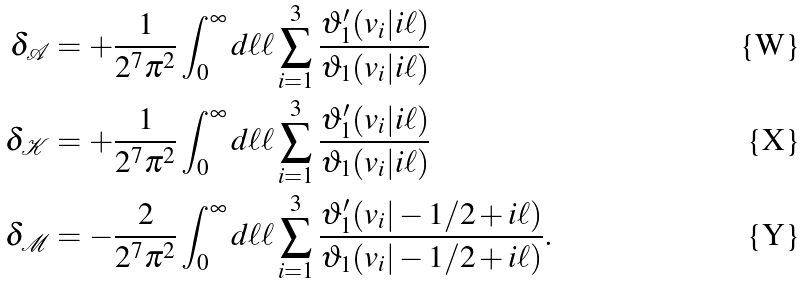<formula> <loc_0><loc_0><loc_500><loc_500>\delta _ { \mathcal { A } } & = + \frac { 1 } { 2 ^ { 7 } \pi ^ { 2 } } \int _ { 0 } ^ { \infty } d \ell \ell \sum _ { i = 1 } ^ { 3 } \frac { \vartheta _ { 1 } ^ { \prime } ( v _ { i } | i \ell ) } { \vartheta _ { 1 } ( v _ { i } | i \ell ) } \\ \delta _ { \mathcal { K } } & = + \frac { 1 } { 2 ^ { 7 } \pi ^ { 2 } } \int _ { 0 } ^ { \infty } d \ell \ell \sum _ { i = 1 } ^ { 3 } \frac { \vartheta _ { 1 } ^ { \prime } ( v _ { i } | i \ell ) } { \vartheta _ { 1 } ( v _ { i } | i \ell ) } \\ \delta _ { \mathcal { M } } & = - \frac { 2 } { 2 ^ { 7 } \pi ^ { 2 } } \int _ { 0 } ^ { \infty } d \ell \ell \sum _ { i = 1 } ^ { 3 } \frac { \vartheta _ { 1 } ^ { \prime } ( v _ { i } | - 1 / 2 + i \ell ) } { \vartheta _ { 1 } ( v _ { i } | - 1 / 2 + i \ell ) } .</formula> 